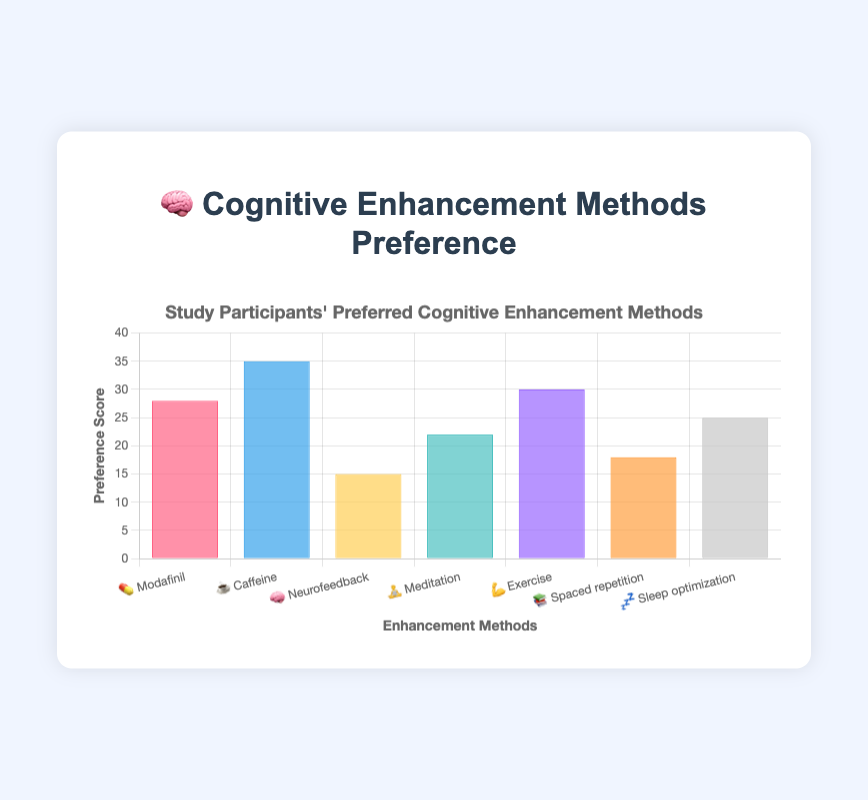What is the title of the chart? The title of the chart is displayed at the top and it reads "🧠 Cognitive Enhancement Methods Preference".
Answer: 🧠 Cognitive Enhancement Methods Preference Which cognitive enhancement method has the highest preference score? By looking at the heights of the bars, the highest preference score is associated with "☕️ Caffeine".
Answer: ☕️ Caffeine How many methods have a preference score of 25 or more? The bars that reach up to or above 25 on the y-axis correspond to "💊 Modafinil", "☕️ Caffeine", "💪 Exercise", and "💤 Sleep optimization". There are 4 such methods.
Answer: 4 Which method has the lowest preference score? The lowest bar represents "🧠 Neurofeedback" with a preference score of 15.
Answer: 🧠 Neurofeedback What is the combined preference score of "💪 Exercise" and "📚 Spaced repetition"? "💪 Exercise" has a score of 30, and "📚 Spaced repetition" has a score of 18. Their combined preference score is 30 + 18 = 48.
Answer: 48 Is the preference score of "🧘 Meditation" higher than that of "💤 Sleep optimization"? Comparing the heights of the bars, "🧘 Meditation" has a score of 22, while "💤 Sleep optimization" has a score of 25. Thus, "🧘 Meditation" is lower.
Answer: No What are the colors used for the "💤 Sleep optimization" bar and the "🧠 Neurofeedback" bar? The bar for "💤 Sleep optimization" is light grey, and the bar for "🧠 Neurofeedback" is yellow.
Answer: light grey and yellow What is the average preference score for all methods? To find the average, sum all the preference scores: 28 + 35 + 15 + 22 + 30 + 18 + 25 = 173. Then divide by the number of methods, which is 7. The average is 173 / 7 = 24.71.
Answer: 24.71 Which method has a preference score that is exactly 5 points higher than "🧘 Meditation"? "🧘 Meditation" has a score of 22. Adding 5 to this gives 27. The closest match is "💊 Modafinil" with a score of 28.
Answer: 💊 Modafinil 